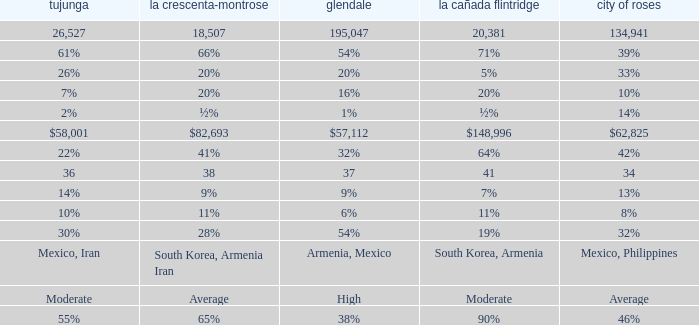What is the figure for Pasadena when Tujunga is 36? 34.0. 